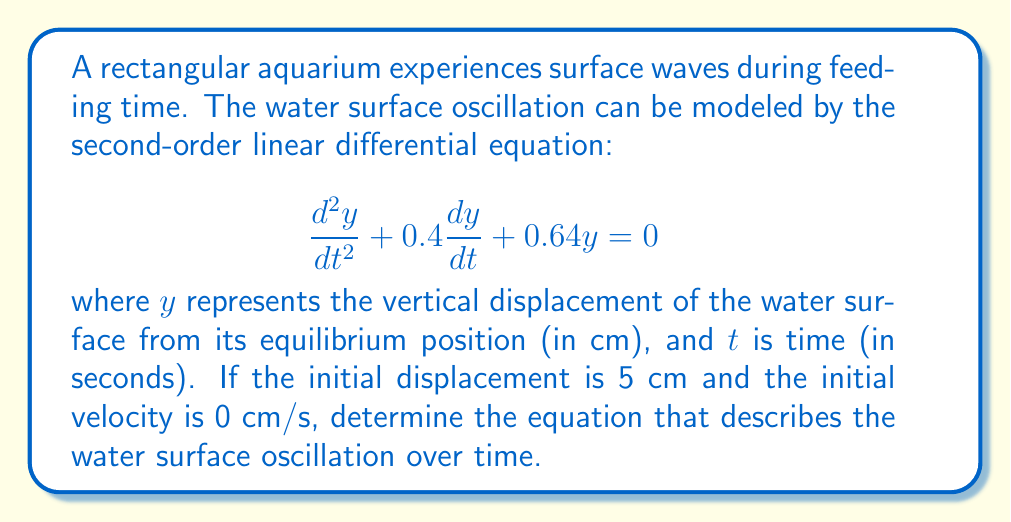Can you answer this question? To solve this problem, we follow these steps:

1) The given differential equation is in the form:
   $$\frac{d^2y}{dt^2} + 2\zeta\omega_n\frac{dy}{dt} + \omega_n^2y = 0$$
   where $\zeta$ is the damping ratio and $\omega_n$ is the natural frequency.

2) Comparing our equation to this form, we can identify:
   $2\zeta\omega_n = 0.4$ and $\omega_n^2 = 0.64$

3) From $\omega_n^2 = 0.64$, we get $\omega_n = 0.8$ rad/s

4) Substituting this into $2\zeta\omega_n = 0.4$, we get:
   $2\zeta(0.8) = 0.4$
   $\zeta = 0.25$

5) Since $0 < \zeta < 1$, this is an underdamped system. The solution has the form:
   $$y(t) = Ae^{-\zeta\omega_n t}\cos(\omega_d t - \phi)$$
   where $\omega_d = \omega_n\sqrt{1-\zeta^2}$ is the damped natural frequency.

6) Calculate $\omega_d$:
   $$\omega_d = 0.8\sqrt{1-0.25^2} = 0.7746$$ rad/s

7) The initial conditions are $y(0) = 5$ cm and $y'(0) = 0$ cm/s. Using these:
   $5 = A\cos(\phi)$
   $0 = -0.2A\cos(\phi) - 0.7746A\sin(\phi)$

8) From the second equation:
   $\tan(\phi) = -0.2581$
   $\phi = -0.2525$ rad

9) Substituting this back into $5 = A\cos(\phi)$:
   $A = \frac{5}{\cos(-0.2525)} = 5.1635$ cm

10) Therefore, the final equation is:
    $$y(t) = 5.1635e^{-0.2t}\cos(0.7746t + 0.2525)$$ cm
Answer: $y(t) = 5.1635e^{-0.2t}\cos(0.7746t + 0.2525)$ cm 